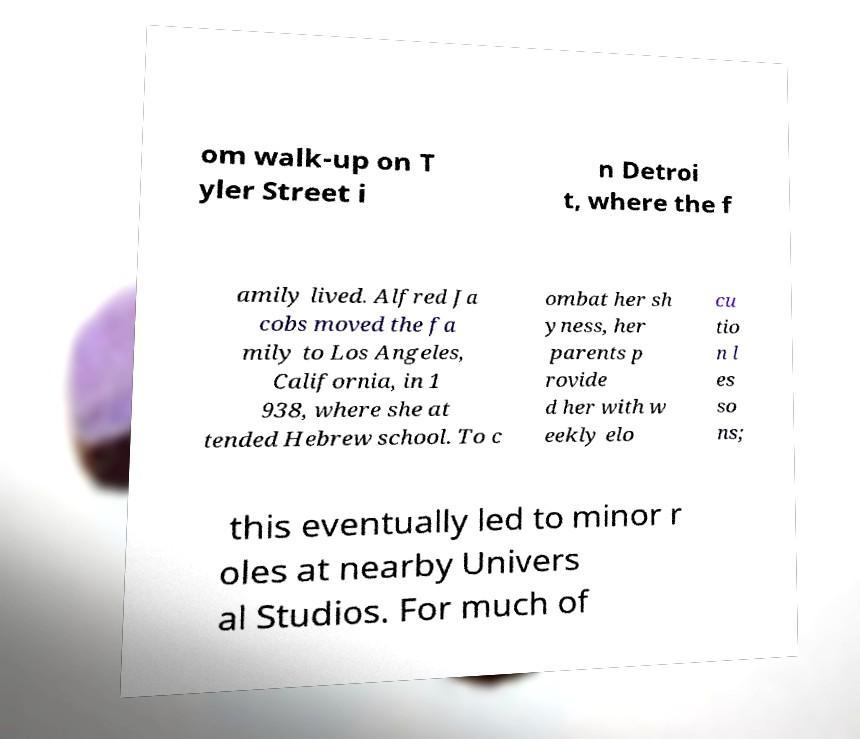What messages or text are displayed in this image? I need them in a readable, typed format. om walk-up on T yler Street i n Detroi t, where the f amily lived. Alfred Ja cobs moved the fa mily to Los Angeles, California, in 1 938, where she at tended Hebrew school. To c ombat her sh yness, her parents p rovide d her with w eekly elo cu tio n l es so ns; this eventually led to minor r oles at nearby Univers al Studios. For much of 